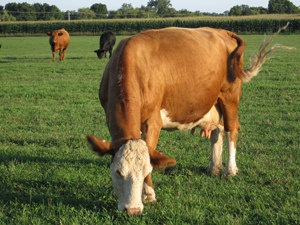Describe the objects in this image and their specific colors. I can see cow in lightgray, brown, orange, black, and maroon tones, cow in lightgray, brown, black, and maroon tones, and cow in lightgray, black, darkgreen, and gray tones in this image. 